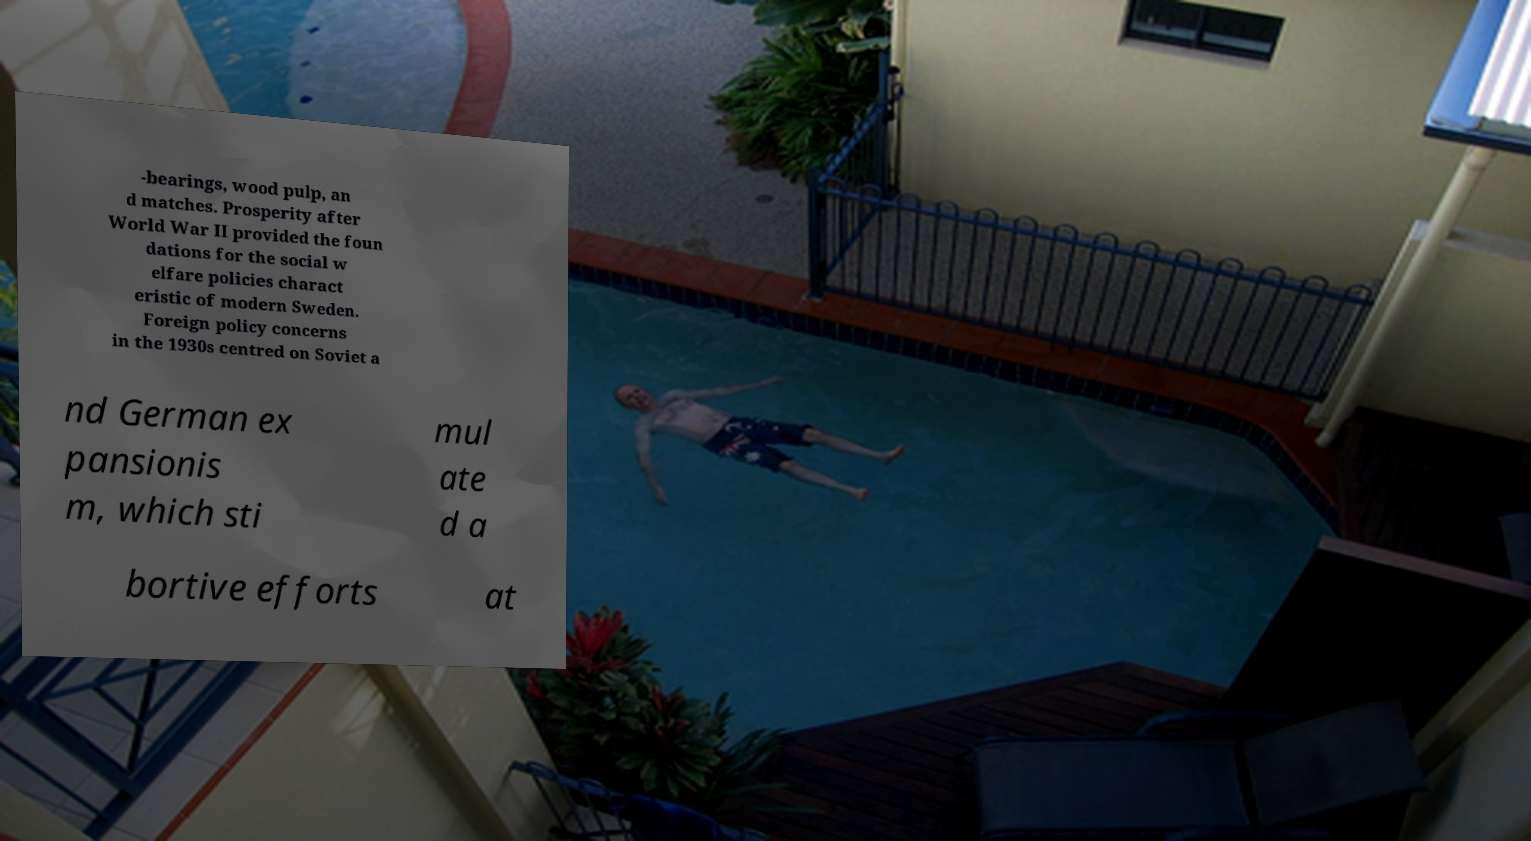For documentation purposes, I need the text within this image transcribed. Could you provide that? -bearings, wood pulp, an d matches. Prosperity after World War II provided the foun dations for the social w elfare policies charact eristic of modern Sweden. Foreign policy concerns in the 1930s centred on Soviet a nd German ex pansionis m, which sti mul ate d a bortive efforts at 